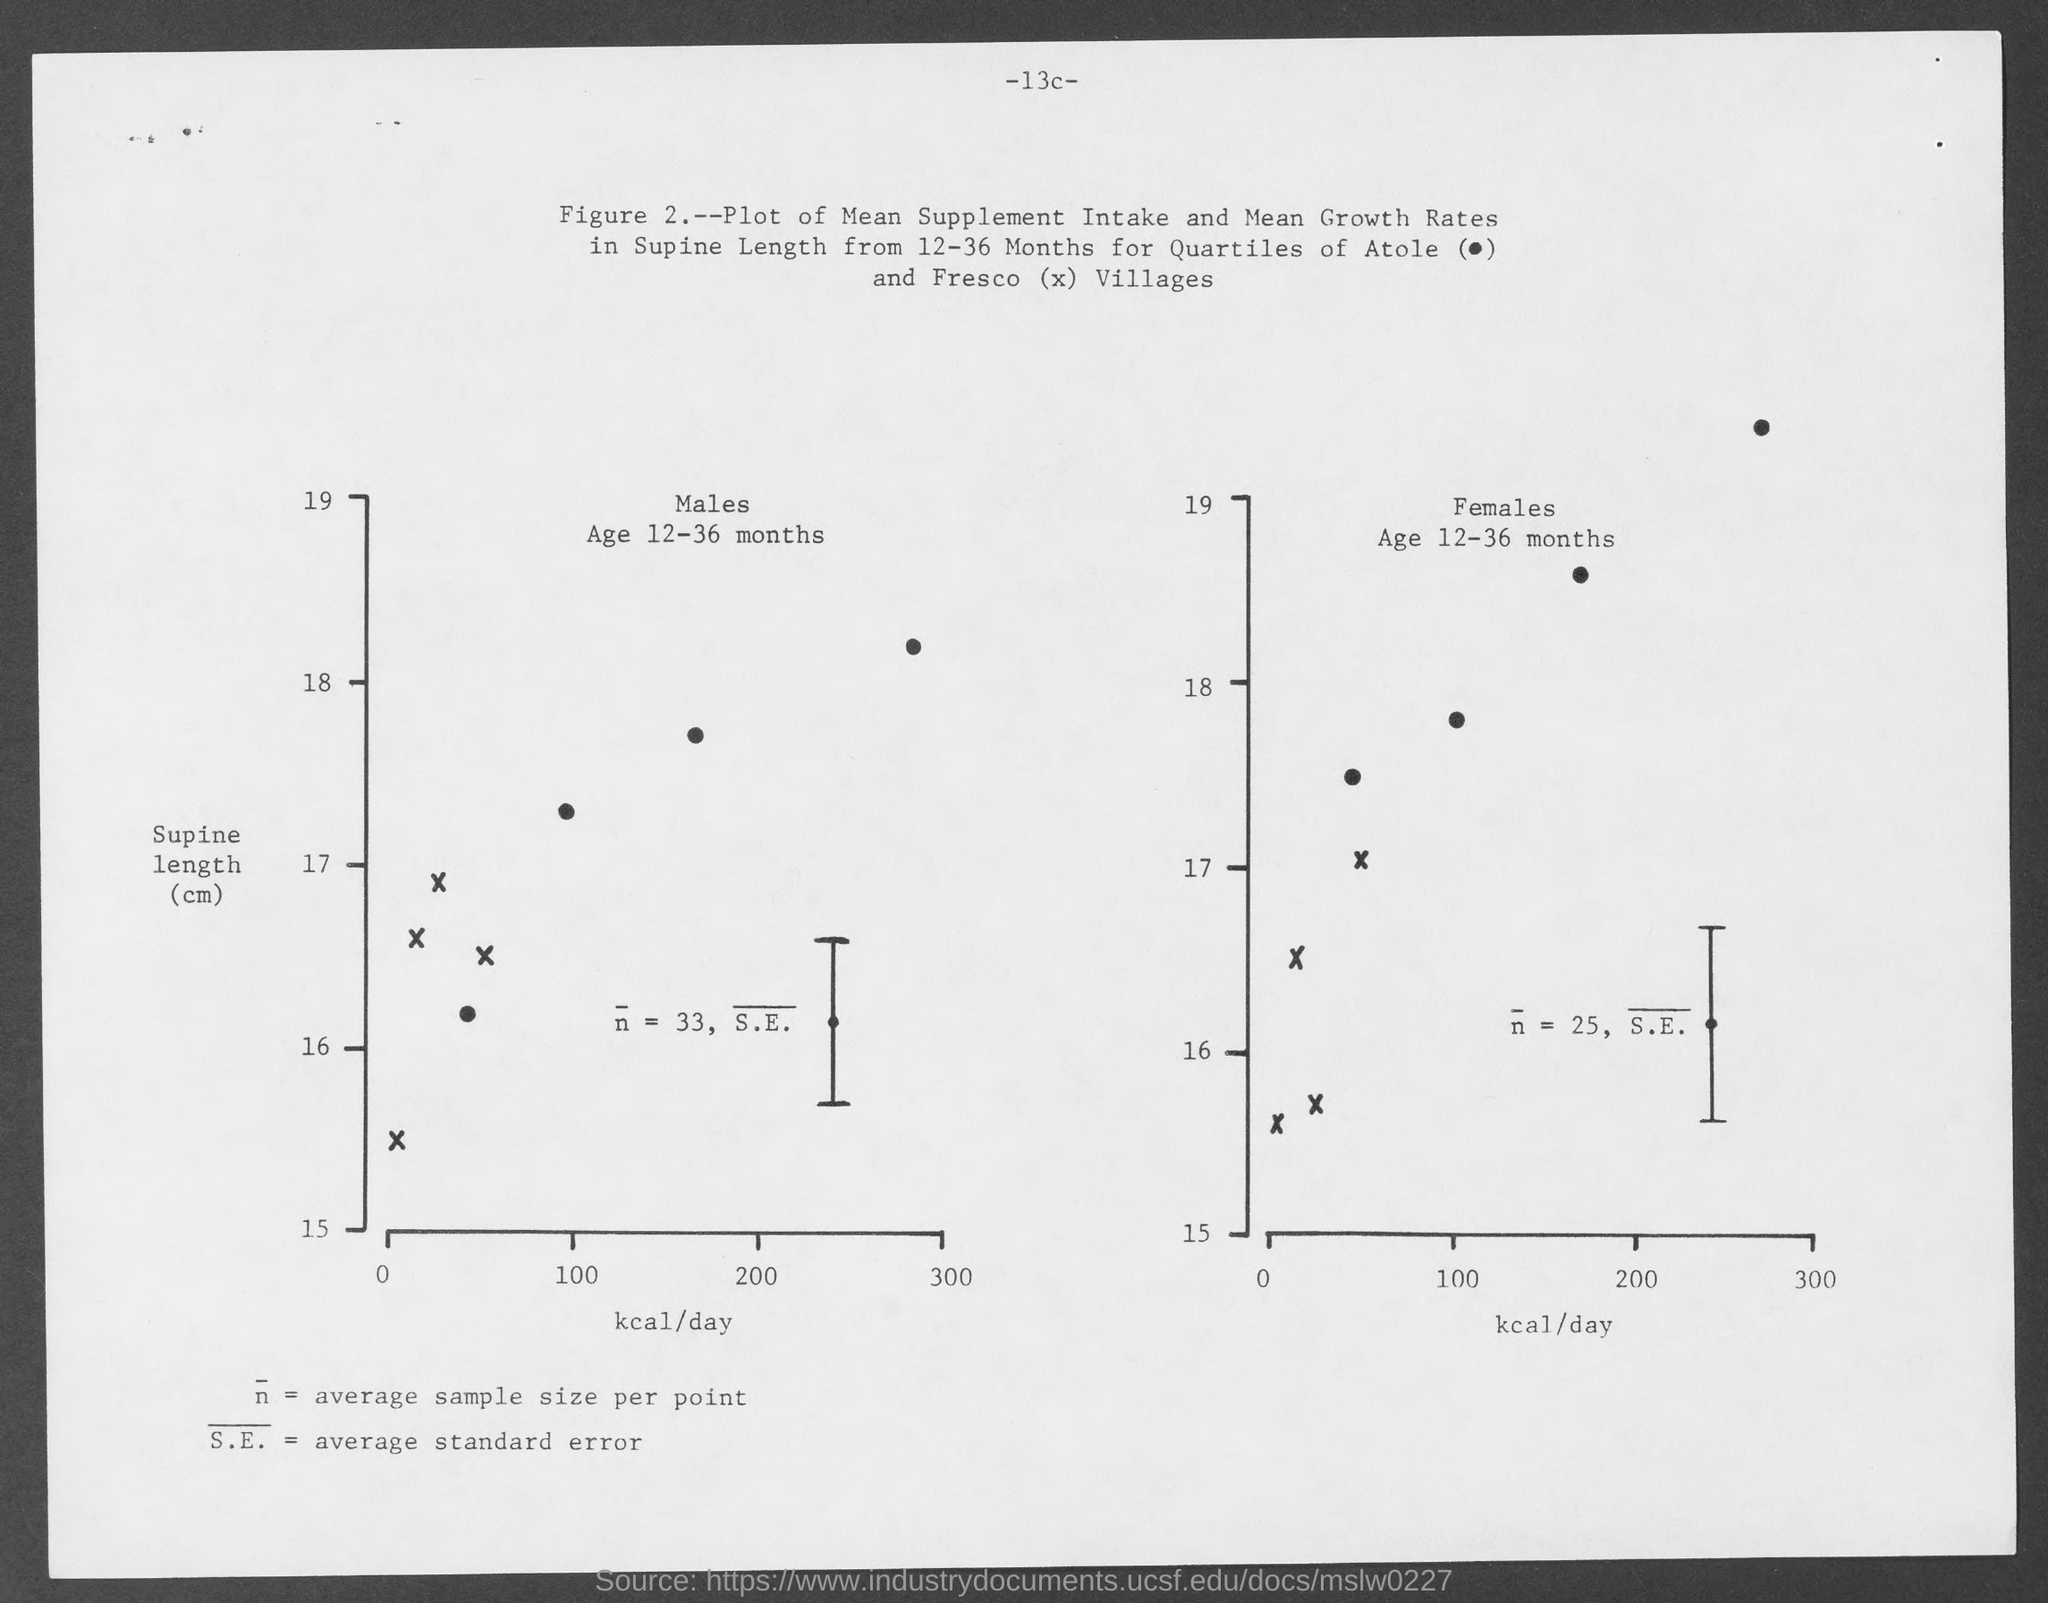What is on the X-axis of the graph?
Offer a very short reply. Kcal/day. What is on the Y-axis of the  graph?
Ensure brevity in your answer.  Supine length(cm). What is the maximum value of kcal/day taken in X-axis?
Your answer should be very brief. 300. What is the maximum value of supine length(cm) taken on y-axis?
Your response must be concise. 19. 